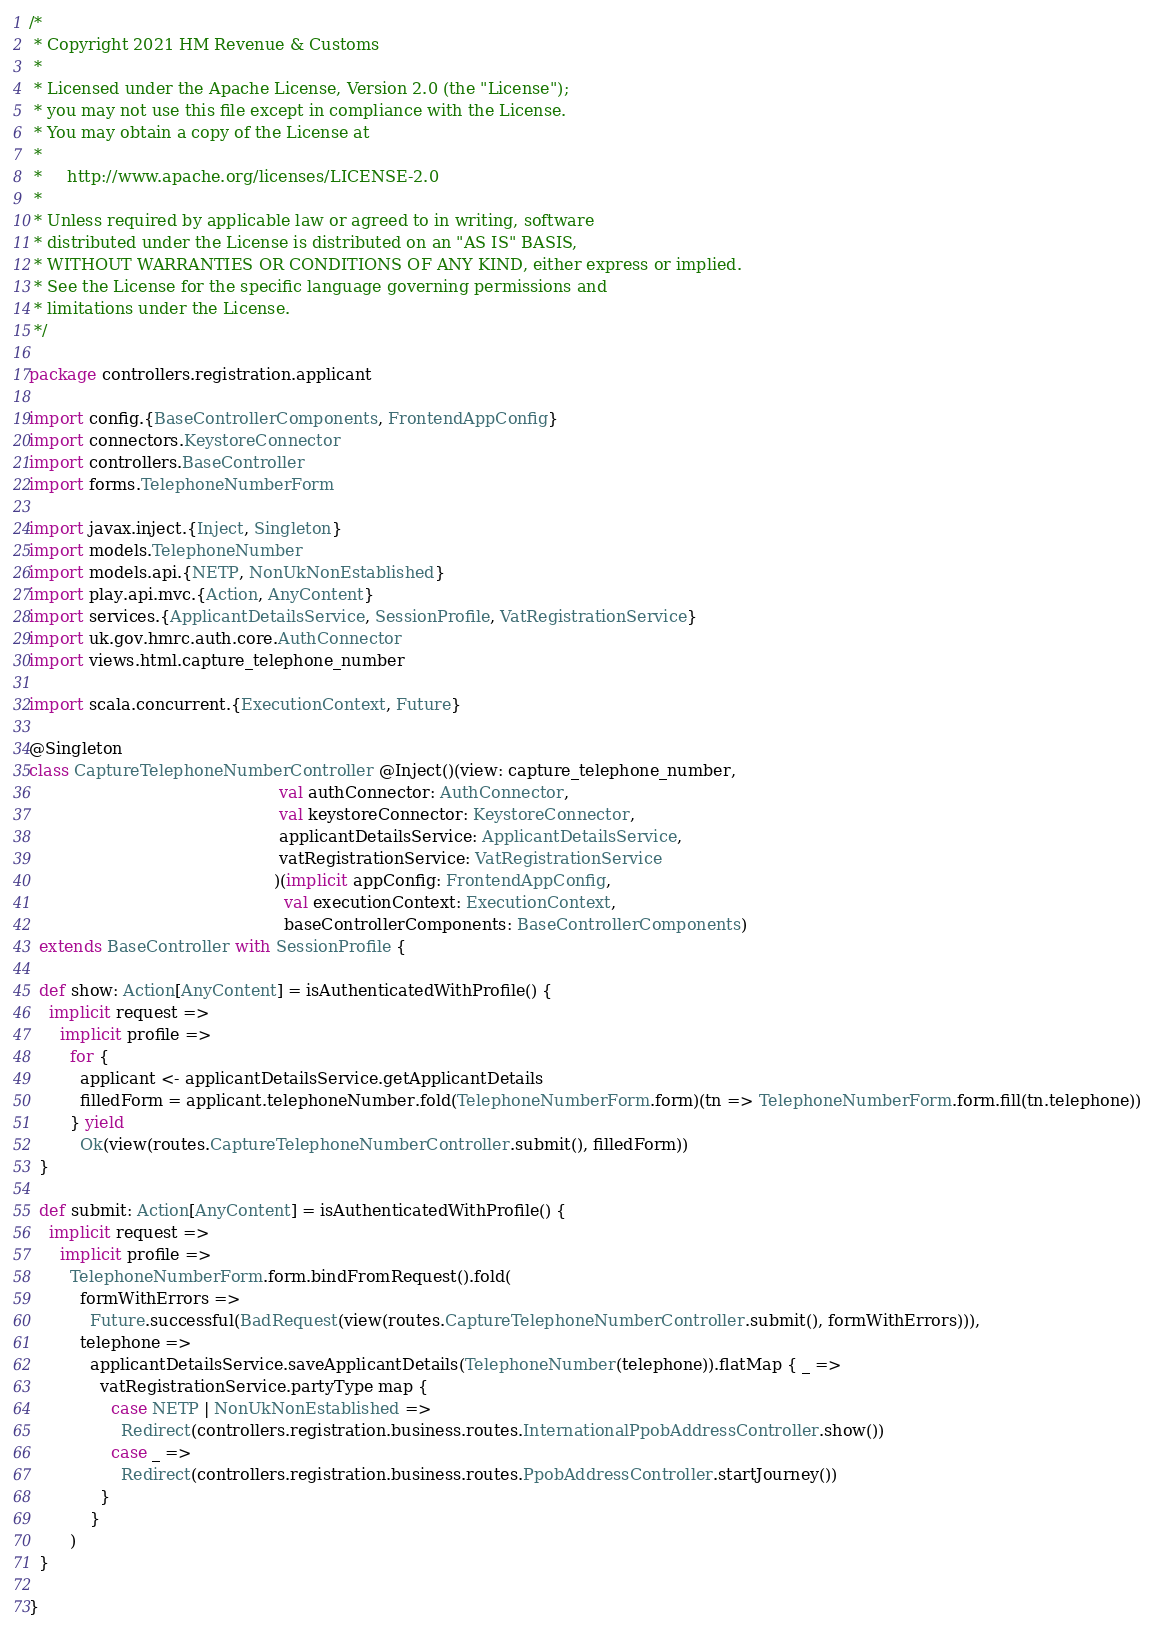Convert code to text. <code><loc_0><loc_0><loc_500><loc_500><_Scala_>/*
 * Copyright 2021 HM Revenue & Customs
 *
 * Licensed under the Apache License, Version 2.0 (the "License");
 * you may not use this file except in compliance with the License.
 * You may obtain a copy of the License at
 *
 *     http://www.apache.org/licenses/LICENSE-2.0
 *
 * Unless required by applicable law or agreed to in writing, software
 * distributed under the License is distributed on an "AS IS" BASIS,
 * WITHOUT WARRANTIES OR CONDITIONS OF ANY KIND, either express or implied.
 * See the License for the specific language governing permissions and
 * limitations under the License.
 */

package controllers.registration.applicant

import config.{BaseControllerComponents, FrontendAppConfig}
import connectors.KeystoreConnector
import controllers.BaseController
import forms.TelephoneNumberForm

import javax.inject.{Inject, Singleton}
import models.TelephoneNumber
import models.api.{NETP, NonUkNonEstablished}
import play.api.mvc.{Action, AnyContent}
import services.{ApplicantDetailsService, SessionProfile, VatRegistrationService}
import uk.gov.hmrc.auth.core.AuthConnector
import views.html.capture_telephone_number

import scala.concurrent.{ExecutionContext, Future}

@Singleton
class CaptureTelephoneNumberController @Inject()(view: capture_telephone_number,
                                                 val authConnector: AuthConnector,
                                                 val keystoreConnector: KeystoreConnector,
                                                 applicantDetailsService: ApplicantDetailsService,
                                                 vatRegistrationService: VatRegistrationService
                                                )(implicit appConfig: FrontendAppConfig,
                                                  val executionContext: ExecutionContext,
                                                  baseControllerComponents: BaseControllerComponents)
  extends BaseController with SessionProfile {

  def show: Action[AnyContent] = isAuthenticatedWithProfile() {
    implicit request =>
      implicit profile =>
        for {
          applicant <- applicantDetailsService.getApplicantDetails
          filledForm = applicant.telephoneNumber.fold(TelephoneNumberForm.form)(tn => TelephoneNumberForm.form.fill(tn.telephone))
        } yield
          Ok(view(routes.CaptureTelephoneNumberController.submit(), filledForm))
  }

  def submit: Action[AnyContent] = isAuthenticatedWithProfile() {
    implicit request =>
      implicit profile =>
        TelephoneNumberForm.form.bindFromRequest().fold(
          formWithErrors =>
            Future.successful(BadRequest(view(routes.CaptureTelephoneNumberController.submit(), formWithErrors))),
          telephone =>
            applicantDetailsService.saveApplicantDetails(TelephoneNumber(telephone)).flatMap { _ =>
              vatRegistrationService.partyType map {
                case NETP | NonUkNonEstablished =>
                  Redirect(controllers.registration.business.routes.InternationalPpobAddressController.show())
                case _ =>
                  Redirect(controllers.registration.business.routes.PpobAddressController.startJourney())
              }
            }
        )
  }

}
</code> 